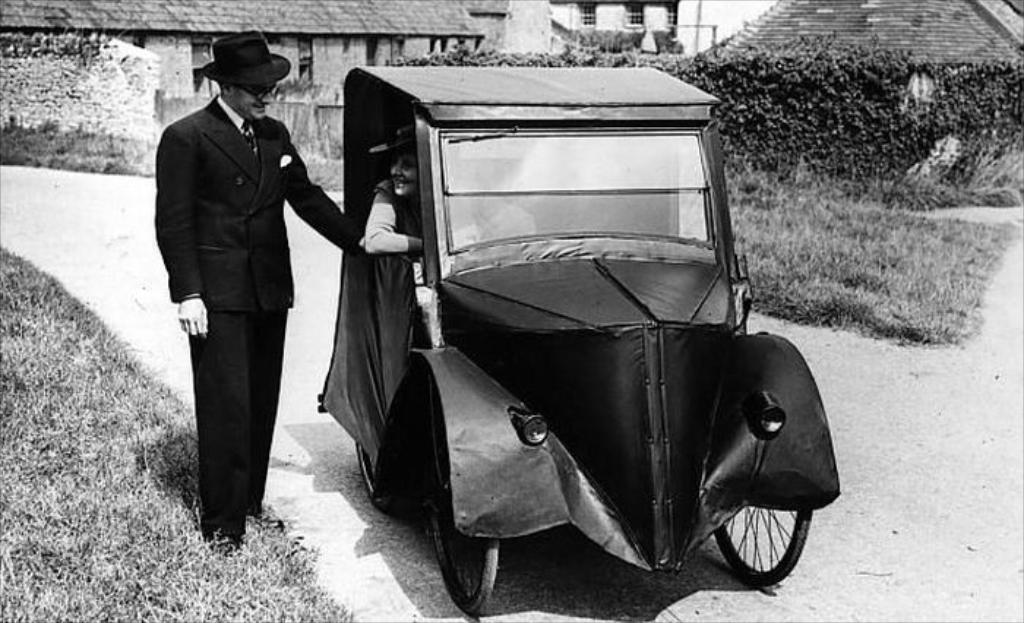What is the color scheme of the image? The image is black and white. What is the man in the image doing? The man is standing on grassy land. What is the woman in the image doing? The woman is sitting in a vehicle. What can be seen in the background of the image? There are plants and buildings in the background of the image. How many cats are visible in the image? There are no cats present in the image. What type of bird can be seen flying in the background of the image? There is no bird visible in the image, as it is a black and white image with no color to indicate the presence of a bird. 